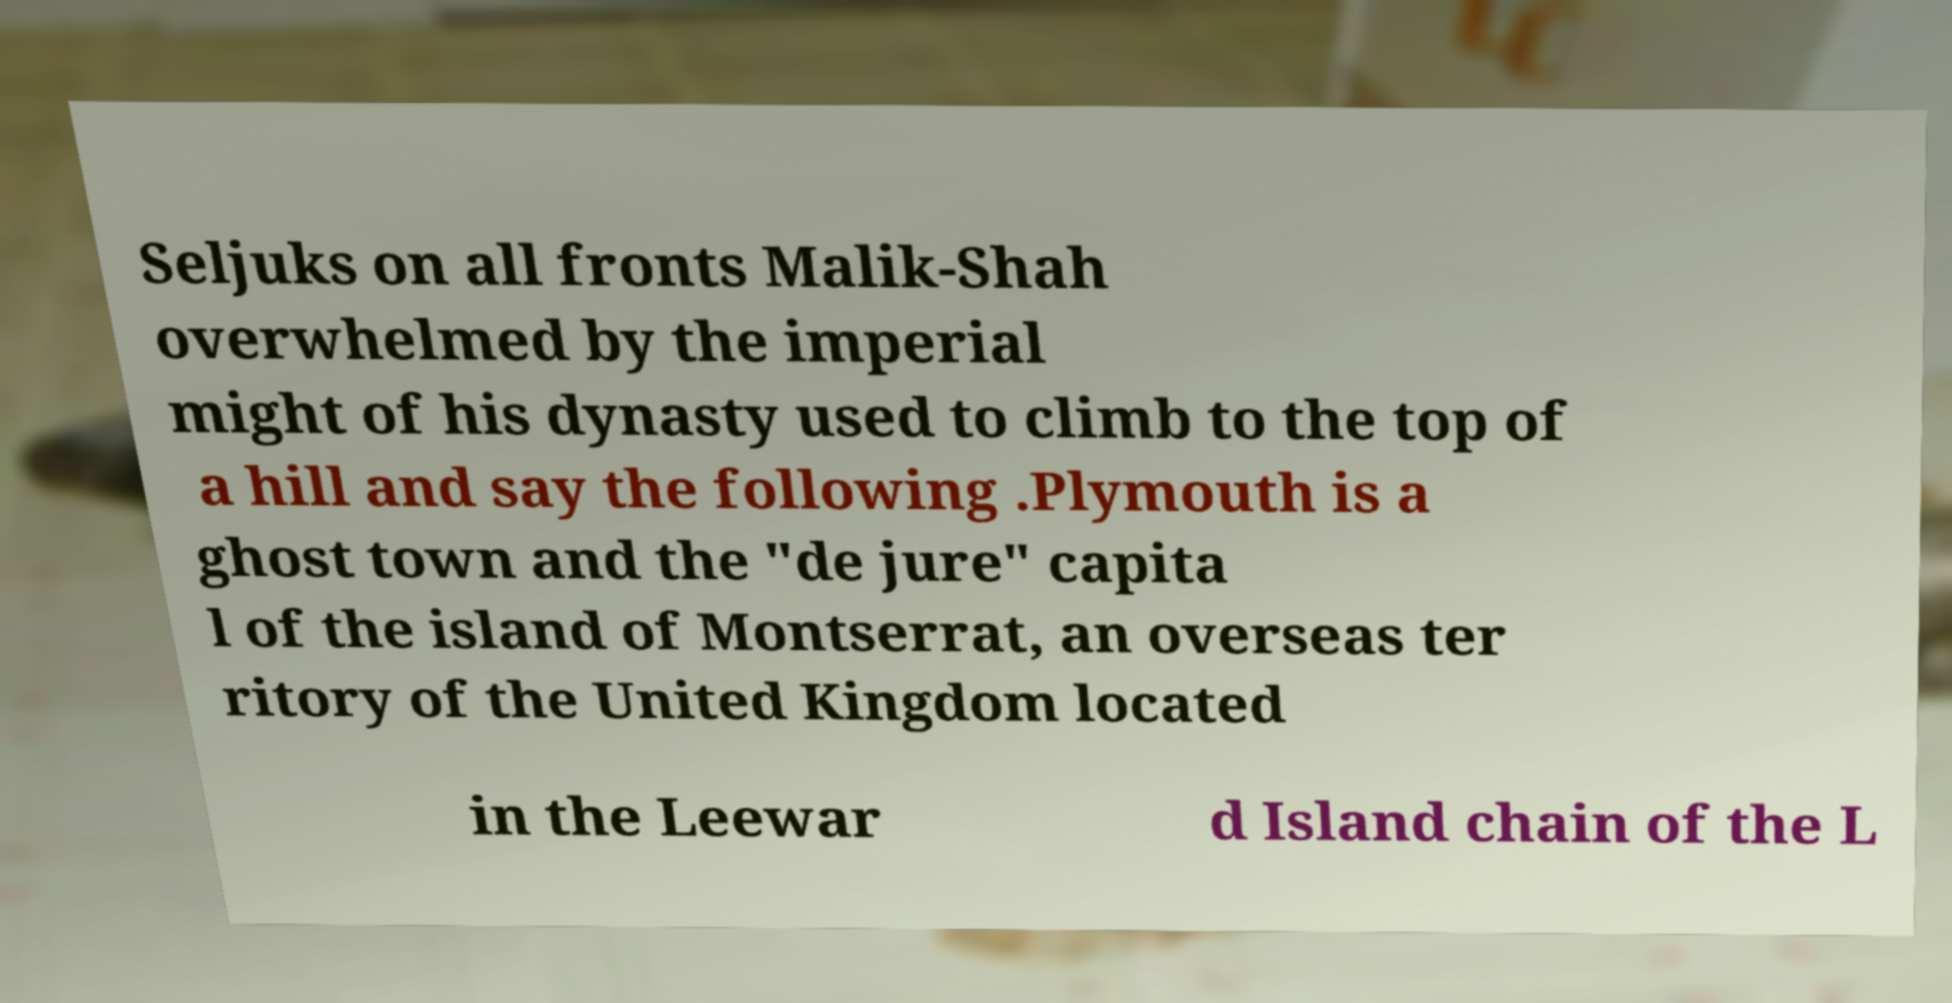Can you accurately transcribe the text from the provided image for me? Seljuks on all fronts Malik-Shah overwhelmed by the imperial might of his dynasty used to climb to the top of a hill and say the following .Plymouth is a ghost town and the "de jure" capita l of the island of Montserrat, an overseas ter ritory of the United Kingdom located in the Leewar d Island chain of the L 